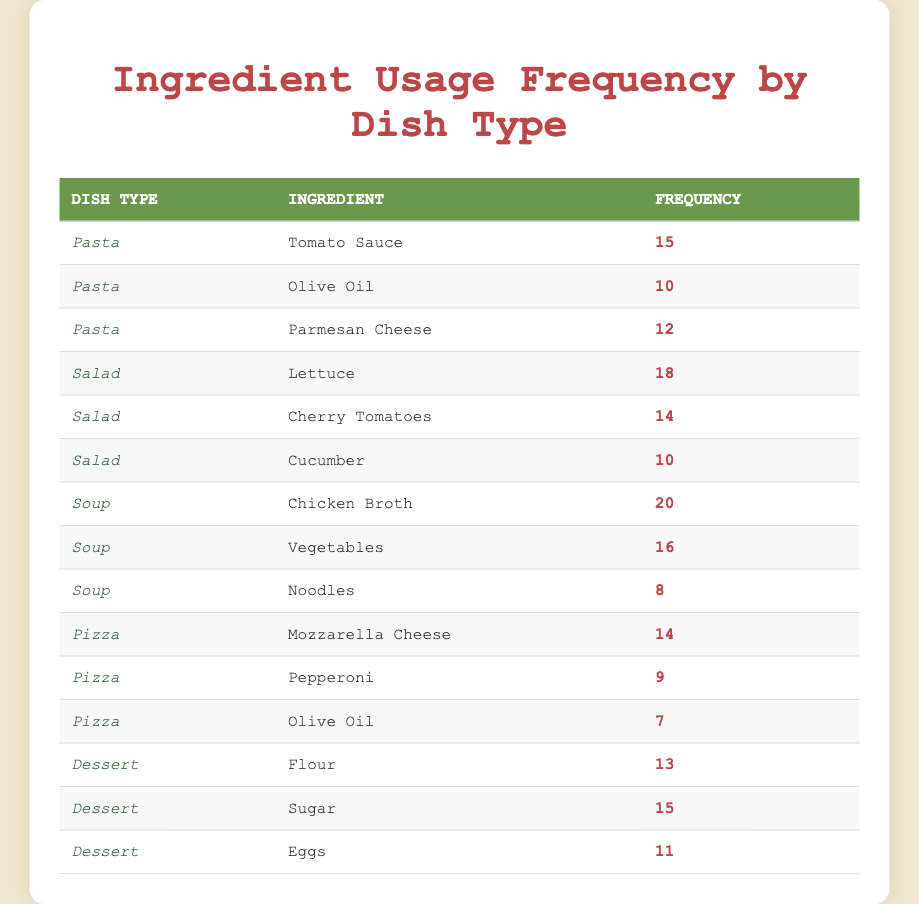What is the highest ingredient frequency in the table? The highest ingredient frequency is found in the "Soup" dish type with "Chicken Broth," which has a frequency of 20.
Answer: 20 Which salad ingredient appears most frequently? By comparing the frequencies of all ingredients under "Salad," "Lettuce" has the highest frequency of 18.
Answer: Lettuce What is the average frequency of ingredients used in Pasta dishes? The frequencies for Pasta are 15, 10, and 12. Summing these gives 15 + 10 + 12 = 37, and there are 3 ingredients, so the average is 37 / 3 = 12.33.
Answer: 12.33 Is Olive Oil used more frequently in Pasta or Pizza dishes? Olive Oil has a frequency of 10 in Pasta and 7 in Pizza, which means it is used more frequently in Pasta by a difference of 3.
Answer: Yes How many ingredients in total are listed for Dessert? The Dessert category lists 3 ingredients: Flour, Sugar, and Eggs. Thus, the total count of ingredients is 3.
Answer: 3 What is the total frequency of ingredients used in Soup dishes? The frequencies of Soup ingredients are 20, 16, and 8. Summing these gives 20 + 16 + 8 = 44.
Answer: 44 Which dish type has the lowest total ingredient frequency? By summing the frequencies for each dish type: Pasta (37), Salad (42), Soup (44), Pizza (30), and Dessert (39), Pizza has the lowest total frequency of 30.
Answer: Pizza Which ingredient has a frequency of 15? Scanning the table, both "Sugar" in Dessert and "Tomato Sauce" in Pasta have a frequency of 15.
Answer: Sugar, Tomato Sauce How does the frequency of Noodles in Soup compare to the frequency of Cherry Tomatoes in Salad? Noodles has a frequency of 8, while Cherry Tomatoes have a frequency of 14; hence, Cherry Tomatoes have a higher frequency by 6.
Answer: Cherry Tomatoes are higher by 6 